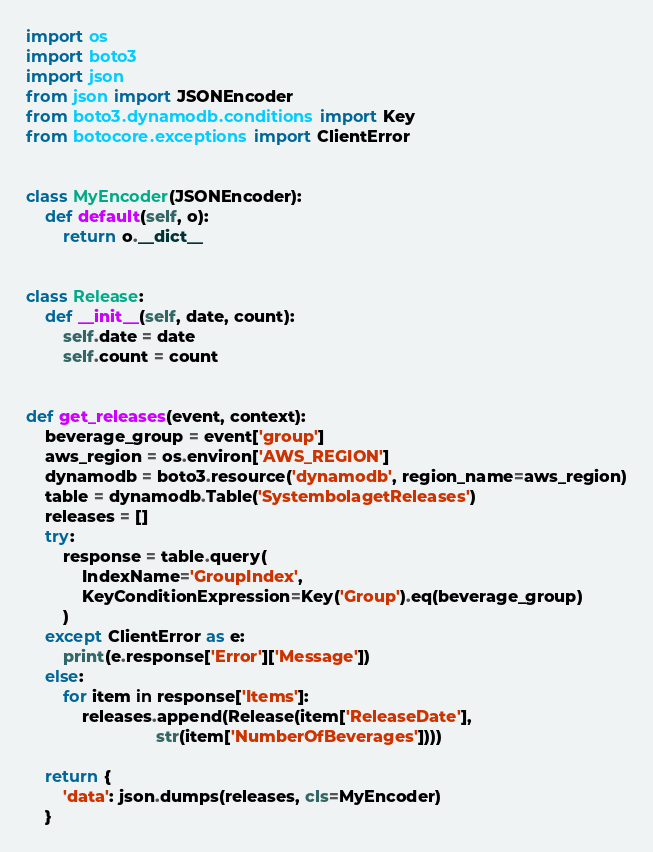Convert code to text. <code><loc_0><loc_0><loc_500><loc_500><_Python_>import os
import boto3
import json
from json import JSONEncoder
from boto3.dynamodb.conditions import Key
from botocore.exceptions import ClientError


class MyEncoder(JSONEncoder):
    def default(self, o):
        return o.__dict__


class Release:
    def __init__(self, date, count):
        self.date = date
        self.count = count


def get_releases(event, context):
    beverage_group = event['group']
    aws_region = os.environ['AWS_REGION']
    dynamodb = boto3.resource('dynamodb', region_name=aws_region)
    table = dynamodb.Table('SystembolagetReleases')
    releases = []
    try:
        response = table.query(
            IndexName='GroupIndex',
            KeyConditionExpression=Key('Group').eq(beverage_group)
        )
    except ClientError as e:
        print(e.response['Error']['Message'])
    else:
        for item in response['Items']:
            releases.append(Release(item['ReleaseDate'],
                            str(item['NumberOfBeverages'])))

    return {
        'data': json.dumps(releases, cls=MyEncoder)
    }
</code> 